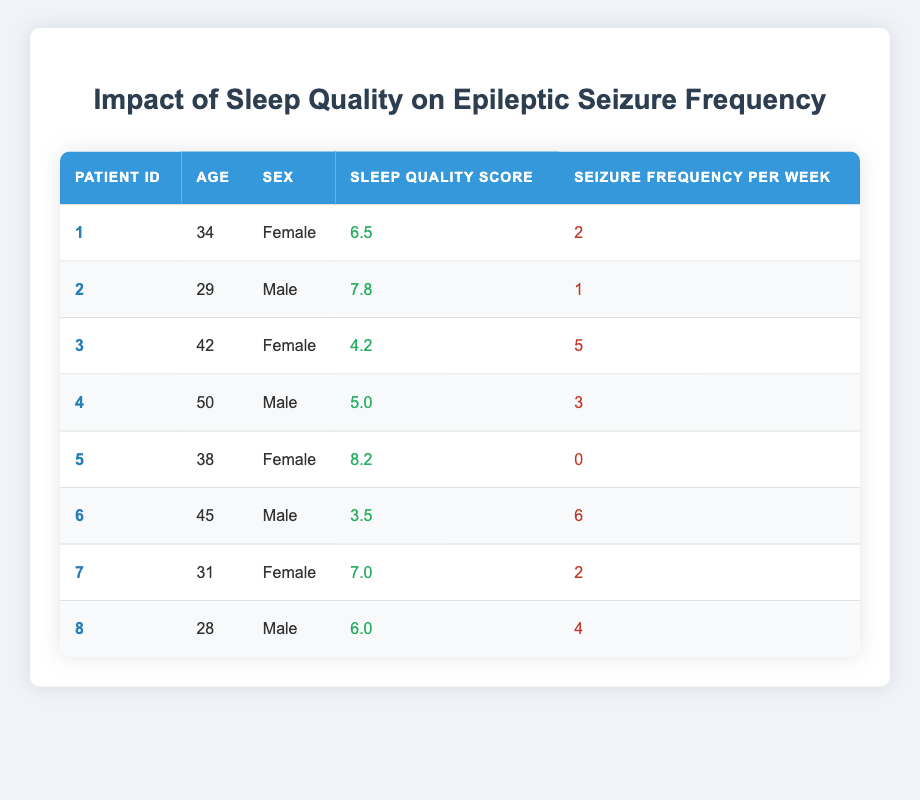What is the highest Sleep Quality Score recorded? The highest value in the Sleep Quality Score column is 8.2, which corresponds to Patient ID 5.
Answer: 8.2 What is the Seizure Frequency Per Week for Patient ID 6? Referring to the table, Patient ID 6 has a Seizure Frequency Per Week of 6.
Answer: 6 How many patients have a Sleep Quality Score greater than 6.0? The patients with scores greater than 6.0 are Patient IDs 2, 5, and 7, totaling 3 patients.
Answer: 3 What is the average Seizure Frequency Per Week for all patients? To find the average, sum the Seizure Frequencies (2 + 1 + 5 + 3 + 0 + 6 + 2 + 4 = 23) and divide by the number of patients (8). The average is 23 / 8 = 2.875.
Answer: 2.875 Does Patient ID 3 have the highest Seizure Frequency Per Week? By examining the table, Patient ID 3 has a frequency of 5, but Patient ID 6 has the highest with 6, so the statement is false.
Answer: No What is the relationship between Sleep Quality Score and Seizure Frequency Per Week? Looking at the table, as the Sleep Quality Score increases, the Seizure Frequency Per Week tends to decrease, indicating a possible negative correlation.
Answer: Negative correlation Which patient is the oldest and what is their Seizure Frequency? The oldest patient is Patient ID 4, aged 50, with a Seizure Frequency of 3 per week.
Answer: 3 Are there any female patients with a Sleep Quality Score below 5? Patient ID 3 has a Sleep Quality Score of 4.2, which is below 5, confirming that there is at least one female patient meeting this criterion.
Answer: Yes What is the median Sleep Quality Score among all patients? To find the median, first list the scores in ascending order: 3.5, 4.2, 5.0, 6.0, 6.5, 7.0, 7.8, 8.2. With 8 scores, the median will be the average of the 4th and 5th values (6.0 and 6.5), resulting in (6.0 + 6.5) / 2 = 6.25.
Answer: 6.25 